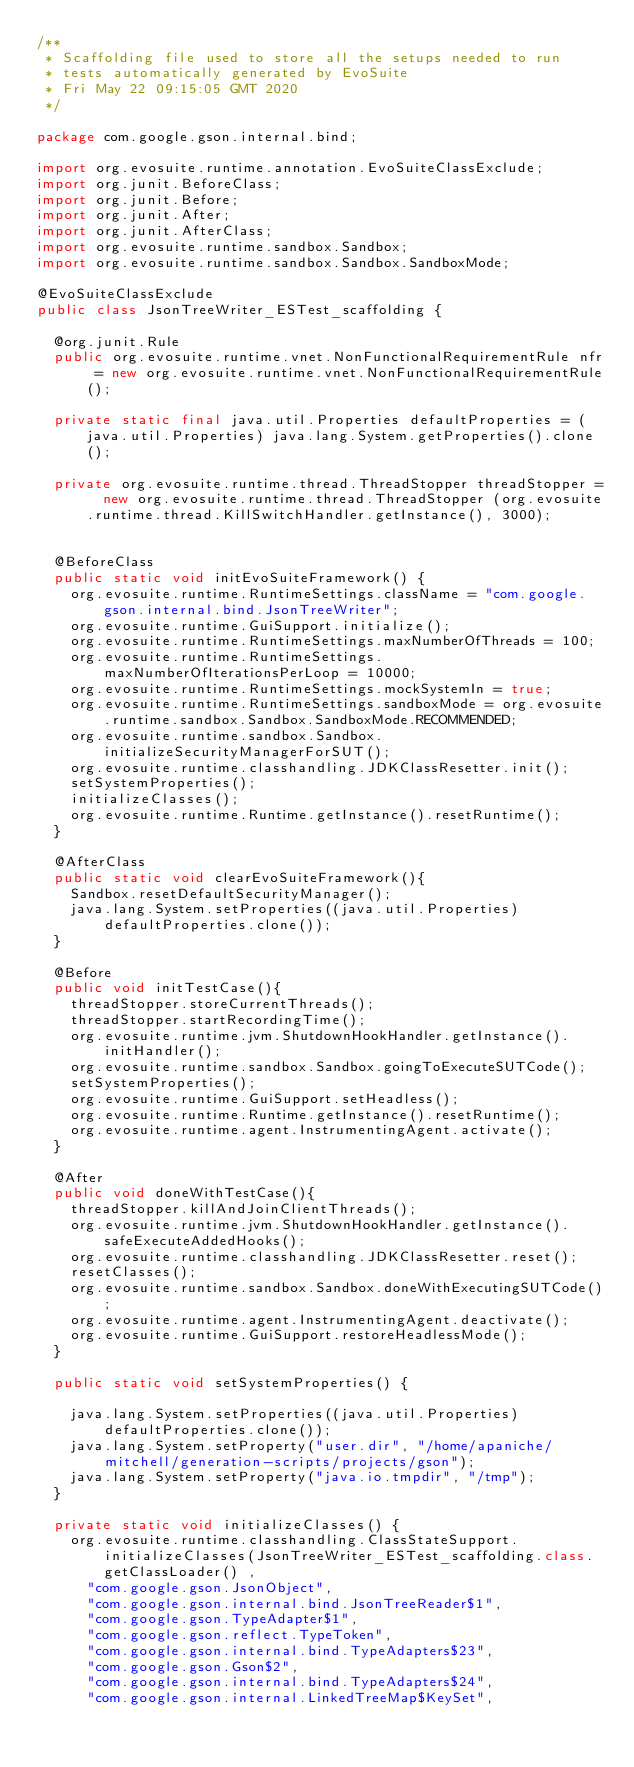Convert code to text. <code><loc_0><loc_0><loc_500><loc_500><_Java_>/**
 * Scaffolding file used to store all the setups needed to run 
 * tests automatically generated by EvoSuite
 * Fri May 22 09:15:05 GMT 2020
 */

package com.google.gson.internal.bind;

import org.evosuite.runtime.annotation.EvoSuiteClassExclude;
import org.junit.BeforeClass;
import org.junit.Before;
import org.junit.After;
import org.junit.AfterClass;
import org.evosuite.runtime.sandbox.Sandbox;
import org.evosuite.runtime.sandbox.Sandbox.SandboxMode;

@EvoSuiteClassExclude
public class JsonTreeWriter_ESTest_scaffolding {

  @org.junit.Rule 
  public org.evosuite.runtime.vnet.NonFunctionalRequirementRule nfr = new org.evosuite.runtime.vnet.NonFunctionalRequirementRule();

  private static final java.util.Properties defaultProperties = (java.util.Properties) java.lang.System.getProperties().clone(); 

  private org.evosuite.runtime.thread.ThreadStopper threadStopper =  new org.evosuite.runtime.thread.ThreadStopper (org.evosuite.runtime.thread.KillSwitchHandler.getInstance(), 3000);


  @BeforeClass 
  public static void initEvoSuiteFramework() { 
    org.evosuite.runtime.RuntimeSettings.className = "com.google.gson.internal.bind.JsonTreeWriter"; 
    org.evosuite.runtime.GuiSupport.initialize(); 
    org.evosuite.runtime.RuntimeSettings.maxNumberOfThreads = 100; 
    org.evosuite.runtime.RuntimeSettings.maxNumberOfIterationsPerLoop = 10000; 
    org.evosuite.runtime.RuntimeSettings.mockSystemIn = true; 
    org.evosuite.runtime.RuntimeSettings.sandboxMode = org.evosuite.runtime.sandbox.Sandbox.SandboxMode.RECOMMENDED; 
    org.evosuite.runtime.sandbox.Sandbox.initializeSecurityManagerForSUT(); 
    org.evosuite.runtime.classhandling.JDKClassResetter.init();
    setSystemProperties();
    initializeClasses();
    org.evosuite.runtime.Runtime.getInstance().resetRuntime(); 
  } 

  @AfterClass 
  public static void clearEvoSuiteFramework(){ 
    Sandbox.resetDefaultSecurityManager(); 
    java.lang.System.setProperties((java.util.Properties) defaultProperties.clone()); 
  } 

  @Before 
  public void initTestCase(){ 
    threadStopper.storeCurrentThreads();
    threadStopper.startRecordingTime();
    org.evosuite.runtime.jvm.ShutdownHookHandler.getInstance().initHandler(); 
    org.evosuite.runtime.sandbox.Sandbox.goingToExecuteSUTCode(); 
    setSystemProperties(); 
    org.evosuite.runtime.GuiSupport.setHeadless(); 
    org.evosuite.runtime.Runtime.getInstance().resetRuntime(); 
    org.evosuite.runtime.agent.InstrumentingAgent.activate(); 
  } 

  @After 
  public void doneWithTestCase(){ 
    threadStopper.killAndJoinClientThreads();
    org.evosuite.runtime.jvm.ShutdownHookHandler.getInstance().safeExecuteAddedHooks(); 
    org.evosuite.runtime.classhandling.JDKClassResetter.reset(); 
    resetClasses(); 
    org.evosuite.runtime.sandbox.Sandbox.doneWithExecutingSUTCode(); 
    org.evosuite.runtime.agent.InstrumentingAgent.deactivate(); 
    org.evosuite.runtime.GuiSupport.restoreHeadlessMode(); 
  } 

  public static void setSystemProperties() {
 
    java.lang.System.setProperties((java.util.Properties) defaultProperties.clone()); 
    java.lang.System.setProperty("user.dir", "/home/apaniche/mitchell/generation-scripts/projects/gson"); 
    java.lang.System.setProperty("java.io.tmpdir", "/tmp"); 
  }

  private static void initializeClasses() {
    org.evosuite.runtime.classhandling.ClassStateSupport.initializeClasses(JsonTreeWriter_ESTest_scaffolding.class.getClassLoader() ,
      "com.google.gson.JsonObject",
      "com.google.gson.internal.bind.JsonTreeReader$1",
      "com.google.gson.TypeAdapter$1",
      "com.google.gson.reflect.TypeToken",
      "com.google.gson.internal.bind.TypeAdapters$23",
      "com.google.gson.Gson$2",
      "com.google.gson.internal.bind.TypeAdapters$24",
      "com.google.gson.internal.LinkedTreeMap$KeySet",</code> 